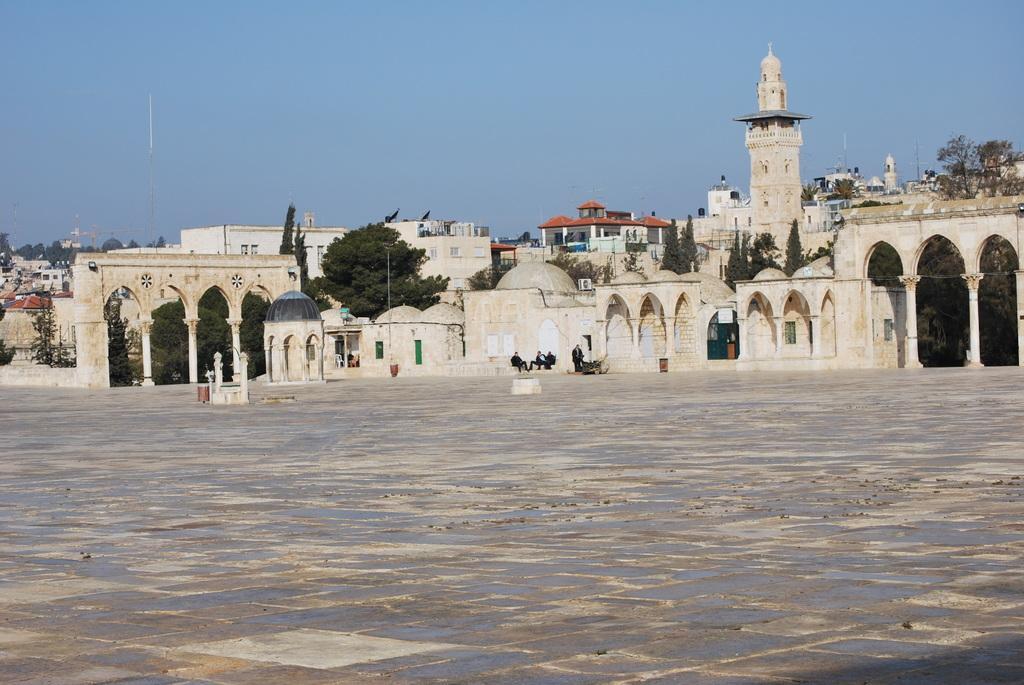Please provide a concise description of this image. In the picture I can see so many buildings, trees and few people are sitting in front of the building. 